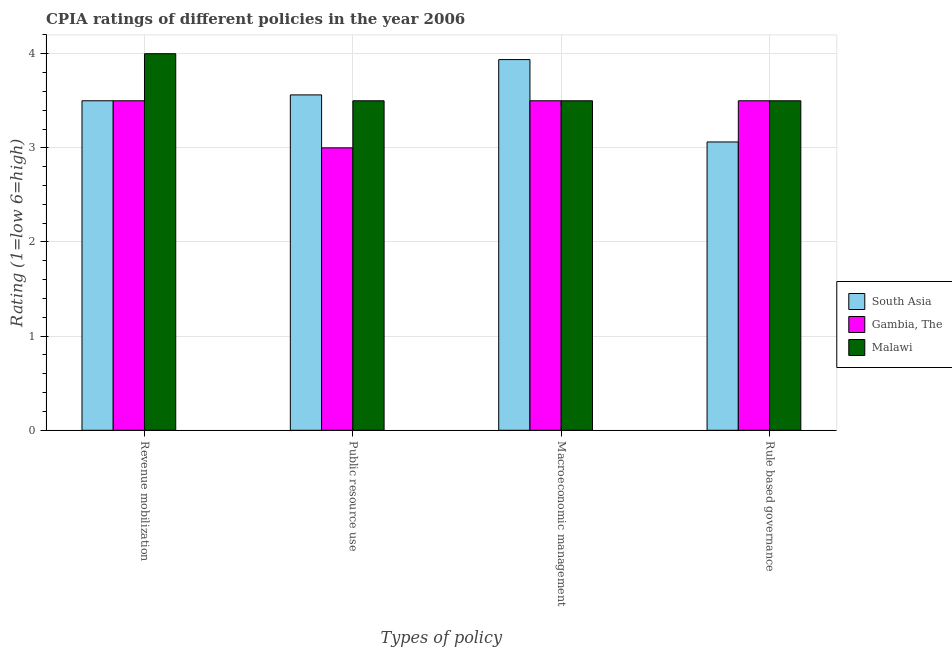How many different coloured bars are there?
Give a very brief answer. 3. Are the number of bars per tick equal to the number of legend labels?
Offer a terse response. Yes. Are the number of bars on each tick of the X-axis equal?
Ensure brevity in your answer.  Yes. How many bars are there on the 4th tick from the left?
Your answer should be compact. 3. What is the label of the 3rd group of bars from the left?
Your answer should be very brief. Macroeconomic management. What is the cpia rating of rule based governance in South Asia?
Make the answer very short. 3.06. Across all countries, what is the minimum cpia rating of rule based governance?
Your response must be concise. 3.06. In which country was the cpia rating of rule based governance maximum?
Your response must be concise. Gambia, The. In which country was the cpia rating of revenue mobilization minimum?
Give a very brief answer. South Asia. What is the total cpia rating of macroeconomic management in the graph?
Offer a very short reply. 10.94. What is the difference between the cpia rating of public resource use in South Asia and that in Gambia, The?
Your answer should be very brief. 0.56. What is the difference between the cpia rating of revenue mobilization in Malawi and the cpia rating of macroeconomic management in South Asia?
Make the answer very short. 0.06. What is the average cpia rating of revenue mobilization per country?
Provide a short and direct response. 3.67. What is the difference between the cpia rating of revenue mobilization and cpia rating of macroeconomic management in South Asia?
Keep it short and to the point. -0.44. What is the ratio of the cpia rating of public resource use in Malawi to that in Gambia, The?
Your answer should be very brief. 1.17. Is the cpia rating of public resource use in South Asia less than that in Malawi?
Your answer should be very brief. No. Is the difference between the cpia rating of public resource use in South Asia and Gambia, The greater than the difference between the cpia rating of macroeconomic management in South Asia and Gambia, The?
Your answer should be very brief. Yes. What is the difference between the highest and the second highest cpia rating of rule based governance?
Offer a very short reply. 0. What is the difference between the highest and the lowest cpia rating of revenue mobilization?
Ensure brevity in your answer.  0.5. Is the sum of the cpia rating of rule based governance in South Asia and Gambia, The greater than the maximum cpia rating of revenue mobilization across all countries?
Your answer should be very brief. Yes. What does the 2nd bar from the left in Rule based governance represents?
Provide a short and direct response. Gambia, The. What does the 2nd bar from the right in Rule based governance represents?
Your response must be concise. Gambia, The. Is it the case that in every country, the sum of the cpia rating of revenue mobilization and cpia rating of public resource use is greater than the cpia rating of macroeconomic management?
Your answer should be compact. Yes. How many bars are there?
Your answer should be compact. 12. Are all the bars in the graph horizontal?
Your answer should be very brief. No. How many countries are there in the graph?
Give a very brief answer. 3. What is the difference between two consecutive major ticks on the Y-axis?
Make the answer very short. 1. Are the values on the major ticks of Y-axis written in scientific E-notation?
Your answer should be compact. No. Does the graph contain any zero values?
Your response must be concise. No. Does the graph contain grids?
Give a very brief answer. Yes. Where does the legend appear in the graph?
Make the answer very short. Center right. What is the title of the graph?
Provide a short and direct response. CPIA ratings of different policies in the year 2006. Does "Malaysia" appear as one of the legend labels in the graph?
Give a very brief answer. No. What is the label or title of the X-axis?
Offer a terse response. Types of policy. What is the Rating (1=low 6=high) of Malawi in Revenue mobilization?
Your response must be concise. 4. What is the Rating (1=low 6=high) of South Asia in Public resource use?
Keep it short and to the point. 3.56. What is the Rating (1=low 6=high) in Malawi in Public resource use?
Your answer should be very brief. 3.5. What is the Rating (1=low 6=high) of South Asia in Macroeconomic management?
Your response must be concise. 3.94. What is the Rating (1=low 6=high) of Gambia, The in Macroeconomic management?
Give a very brief answer. 3.5. What is the Rating (1=low 6=high) of Malawi in Macroeconomic management?
Offer a very short reply. 3.5. What is the Rating (1=low 6=high) in South Asia in Rule based governance?
Your response must be concise. 3.06. Across all Types of policy, what is the maximum Rating (1=low 6=high) in South Asia?
Provide a short and direct response. 3.94. Across all Types of policy, what is the maximum Rating (1=low 6=high) of Gambia, The?
Give a very brief answer. 3.5. Across all Types of policy, what is the maximum Rating (1=low 6=high) in Malawi?
Your answer should be very brief. 4. Across all Types of policy, what is the minimum Rating (1=low 6=high) in South Asia?
Offer a very short reply. 3.06. Across all Types of policy, what is the minimum Rating (1=low 6=high) in Malawi?
Give a very brief answer. 3.5. What is the total Rating (1=low 6=high) in South Asia in the graph?
Your answer should be very brief. 14.06. What is the total Rating (1=low 6=high) in Malawi in the graph?
Make the answer very short. 14.5. What is the difference between the Rating (1=low 6=high) of South Asia in Revenue mobilization and that in Public resource use?
Keep it short and to the point. -0.06. What is the difference between the Rating (1=low 6=high) of Gambia, The in Revenue mobilization and that in Public resource use?
Make the answer very short. 0.5. What is the difference between the Rating (1=low 6=high) of Malawi in Revenue mobilization and that in Public resource use?
Give a very brief answer. 0.5. What is the difference between the Rating (1=low 6=high) of South Asia in Revenue mobilization and that in Macroeconomic management?
Your response must be concise. -0.44. What is the difference between the Rating (1=low 6=high) in Gambia, The in Revenue mobilization and that in Macroeconomic management?
Give a very brief answer. 0. What is the difference between the Rating (1=low 6=high) of South Asia in Revenue mobilization and that in Rule based governance?
Make the answer very short. 0.44. What is the difference between the Rating (1=low 6=high) of Malawi in Revenue mobilization and that in Rule based governance?
Provide a succinct answer. 0.5. What is the difference between the Rating (1=low 6=high) in South Asia in Public resource use and that in Macroeconomic management?
Provide a succinct answer. -0.38. What is the difference between the Rating (1=low 6=high) of Gambia, The in Public resource use and that in Macroeconomic management?
Keep it short and to the point. -0.5. What is the difference between the Rating (1=low 6=high) of South Asia in Public resource use and that in Rule based governance?
Ensure brevity in your answer.  0.5. What is the difference between the Rating (1=low 6=high) of Gambia, The in Public resource use and that in Rule based governance?
Offer a terse response. -0.5. What is the difference between the Rating (1=low 6=high) of South Asia in Macroeconomic management and that in Rule based governance?
Provide a succinct answer. 0.88. What is the difference between the Rating (1=low 6=high) of Gambia, The in Macroeconomic management and that in Rule based governance?
Ensure brevity in your answer.  0. What is the difference between the Rating (1=low 6=high) of Malawi in Macroeconomic management and that in Rule based governance?
Offer a very short reply. 0. What is the difference between the Rating (1=low 6=high) in South Asia in Revenue mobilization and the Rating (1=low 6=high) in Malawi in Public resource use?
Keep it short and to the point. 0. What is the difference between the Rating (1=low 6=high) of South Asia in Public resource use and the Rating (1=low 6=high) of Gambia, The in Macroeconomic management?
Ensure brevity in your answer.  0.06. What is the difference between the Rating (1=low 6=high) in South Asia in Public resource use and the Rating (1=low 6=high) in Malawi in Macroeconomic management?
Provide a short and direct response. 0.06. What is the difference between the Rating (1=low 6=high) of Gambia, The in Public resource use and the Rating (1=low 6=high) of Malawi in Macroeconomic management?
Your response must be concise. -0.5. What is the difference between the Rating (1=low 6=high) of South Asia in Public resource use and the Rating (1=low 6=high) of Gambia, The in Rule based governance?
Provide a short and direct response. 0.06. What is the difference between the Rating (1=low 6=high) of South Asia in Public resource use and the Rating (1=low 6=high) of Malawi in Rule based governance?
Provide a succinct answer. 0.06. What is the difference between the Rating (1=low 6=high) of Gambia, The in Public resource use and the Rating (1=low 6=high) of Malawi in Rule based governance?
Offer a very short reply. -0.5. What is the difference between the Rating (1=low 6=high) of South Asia in Macroeconomic management and the Rating (1=low 6=high) of Gambia, The in Rule based governance?
Your answer should be very brief. 0.44. What is the difference between the Rating (1=low 6=high) of South Asia in Macroeconomic management and the Rating (1=low 6=high) of Malawi in Rule based governance?
Ensure brevity in your answer.  0.44. What is the difference between the Rating (1=low 6=high) in Gambia, The in Macroeconomic management and the Rating (1=low 6=high) in Malawi in Rule based governance?
Give a very brief answer. 0. What is the average Rating (1=low 6=high) of South Asia per Types of policy?
Offer a very short reply. 3.52. What is the average Rating (1=low 6=high) in Gambia, The per Types of policy?
Your response must be concise. 3.38. What is the average Rating (1=low 6=high) of Malawi per Types of policy?
Keep it short and to the point. 3.62. What is the difference between the Rating (1=low 6=high) in South Asia and Rating (1=low 6=high) in Gambia, The in Revenue mobilization?
Give a very brief answer. 0. What is the difference between the Rating (1=low 6=high) in South Asia and Rating (1=low 6=high) in Malawi in Revenue mobilization?
Your answer should be compact. -0.5. What is the difference between the Rating (1=low 6=high) in Gambia, The and Rating (1=low 6=high) in Malawi in Revenue mobilization?
Keep it short and to the point. -0.5. What is the difference between the Rating (1=low 6=high) in South Asia and Rating (1=low 6=high) in Gambia, The in Public resource use?
Ensure brevity in your answer.  0.56. What is the difference between the Rating (1=low 6=high) in South Asia and Rating (1=low 6=high) in Malawi in Public resource use?
Your answer should be compact. 0.06. What is the difference between the Rating (1=low 6=high) of Gambia, The and Rating (1=low 6=high) of Malawi in Public resource use?
Keep it short and to the point. -0.5. What is the difference between the Rating (1=low 6=high) of South Asia and Rating (1=low 6=high) of Gambia, The in Macroeconomic management?
Your answer should be compact. 0.44. What is the difference between the Rating (1=low 6=high) in South Asia and Rating (1=low 6=high) in Malawi in Macroeconomic management?
Offer a very short reply. 0.44. What is the difference between the Rating (1=low 6=high) of South Asia and Rating (1=low 6=high) of Gambia, The in Rule based governance?
Make the answer very short. -0.44. What is the difference between the Rating (1=low 6=high) of South Asia and Rating (1=low 6=high) of Malawi in Rule based governance?
Provide a short and direct response. -0.44. What is the ratio of the Rating (1=low 6=high) in South Asia in Revenue mobilization to that in Public resource use?
Offer a very short reply. 0.98. What is the ratio of the Rating (1=low 6=high) of Gambia, The in Revenue mobilization to that in Public resource use?
Provide a succinct answer. 1.17. What is the ratio of the Rating (1=low 6=high) in South Asia in Revenue mobilization to that in Rule based governance?
Offer a very short reply. 1.14. What is the ratio of the Rating (1=low 6=high) of Gambia, The in Revenue mobilization to that in Rule based governance?
Your response must be concise. 1. What is the ratio of the Rating (1=low 6=high) of South Asia in Public resource use to that in Macroeconomic management?
Your answer should be very brief. 0.9. What is the ratio of the Rating (1=low 6=high) of Gambia, The in Public resource use to that in Macroeconomic management?
Your answer should be very brief. 0.86. What is the ratio of the Rating (1=low 6=high) in Malawi in Public resource use to that in Macroeconomic management?
Provide a short and direct response. 1. What is the ratio of the Rating (1=low 6=high) of South Asia in Public resource use to that in Rule based governance?
Your answer should be compact. 1.16. What is the ratio of the Rating (1=low 6=high) in Gambia, The in Public resource use to that in Rule based governance?
Offer a terse response. 0.86. What is the ratio of the Rating (1=low 6=high) in Malawi in Public resource use to that in Rule based governance?
Give a very brief answer. 1. What is the ratio of the Rating (1=low 6=high) of Gambia, The in Macroeconomic management to that in Rule based governance?
Make the answer very short. 1. What is the ratio of the Rating (1=low 6=high) of Malawi in Macroeconomic management to that in Rule based governance?
Offer a terse response. 1. What is the difference between the highest and the second highest Rating (1=low 6=high) of South Asia?
Your response must be concise. 0.38. What is the difference between the highest and the second highest Rating (1=low 6=high) of Gambia, The?
Keep it short and to the point. 0. What is the difference between the highest and the second highest Rating (1=low 6=high) in Malawi?
Ensure brevity in your answer.  0.5. What is the difference between the highest and the lowest Rating (1=low 6=high) in Gambia, The?
Offer a terse response. 0.5. 